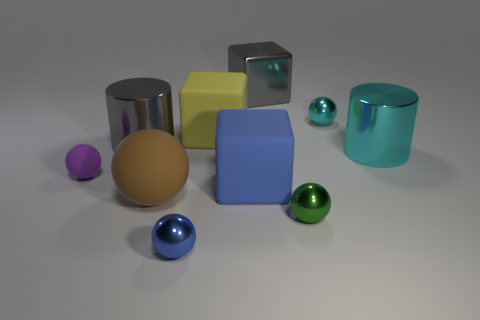Subtract all large rubber blocks. How many blocks are left? 1 Subtract all green balls. How many balls are left? 4 Subtract 3 balls. How many balls are left? 2 Add 5 purple balls. How many purple balls exist? 6 Subtract 0 red blocks. How many objects are left? 10 Subtract all cylinders. How many objects are left? 8 Subtract all blue blocks. Subtract all red spheres. How many blocks are left? 2 Subtract all cyan cylinders. How many red spheres are left? 0 Subtract all large gray metal blocks. Subtract all blue spheres. How many objects are left? 8 Add 1 large gray blocks. How many large gray blocks are left? 2 